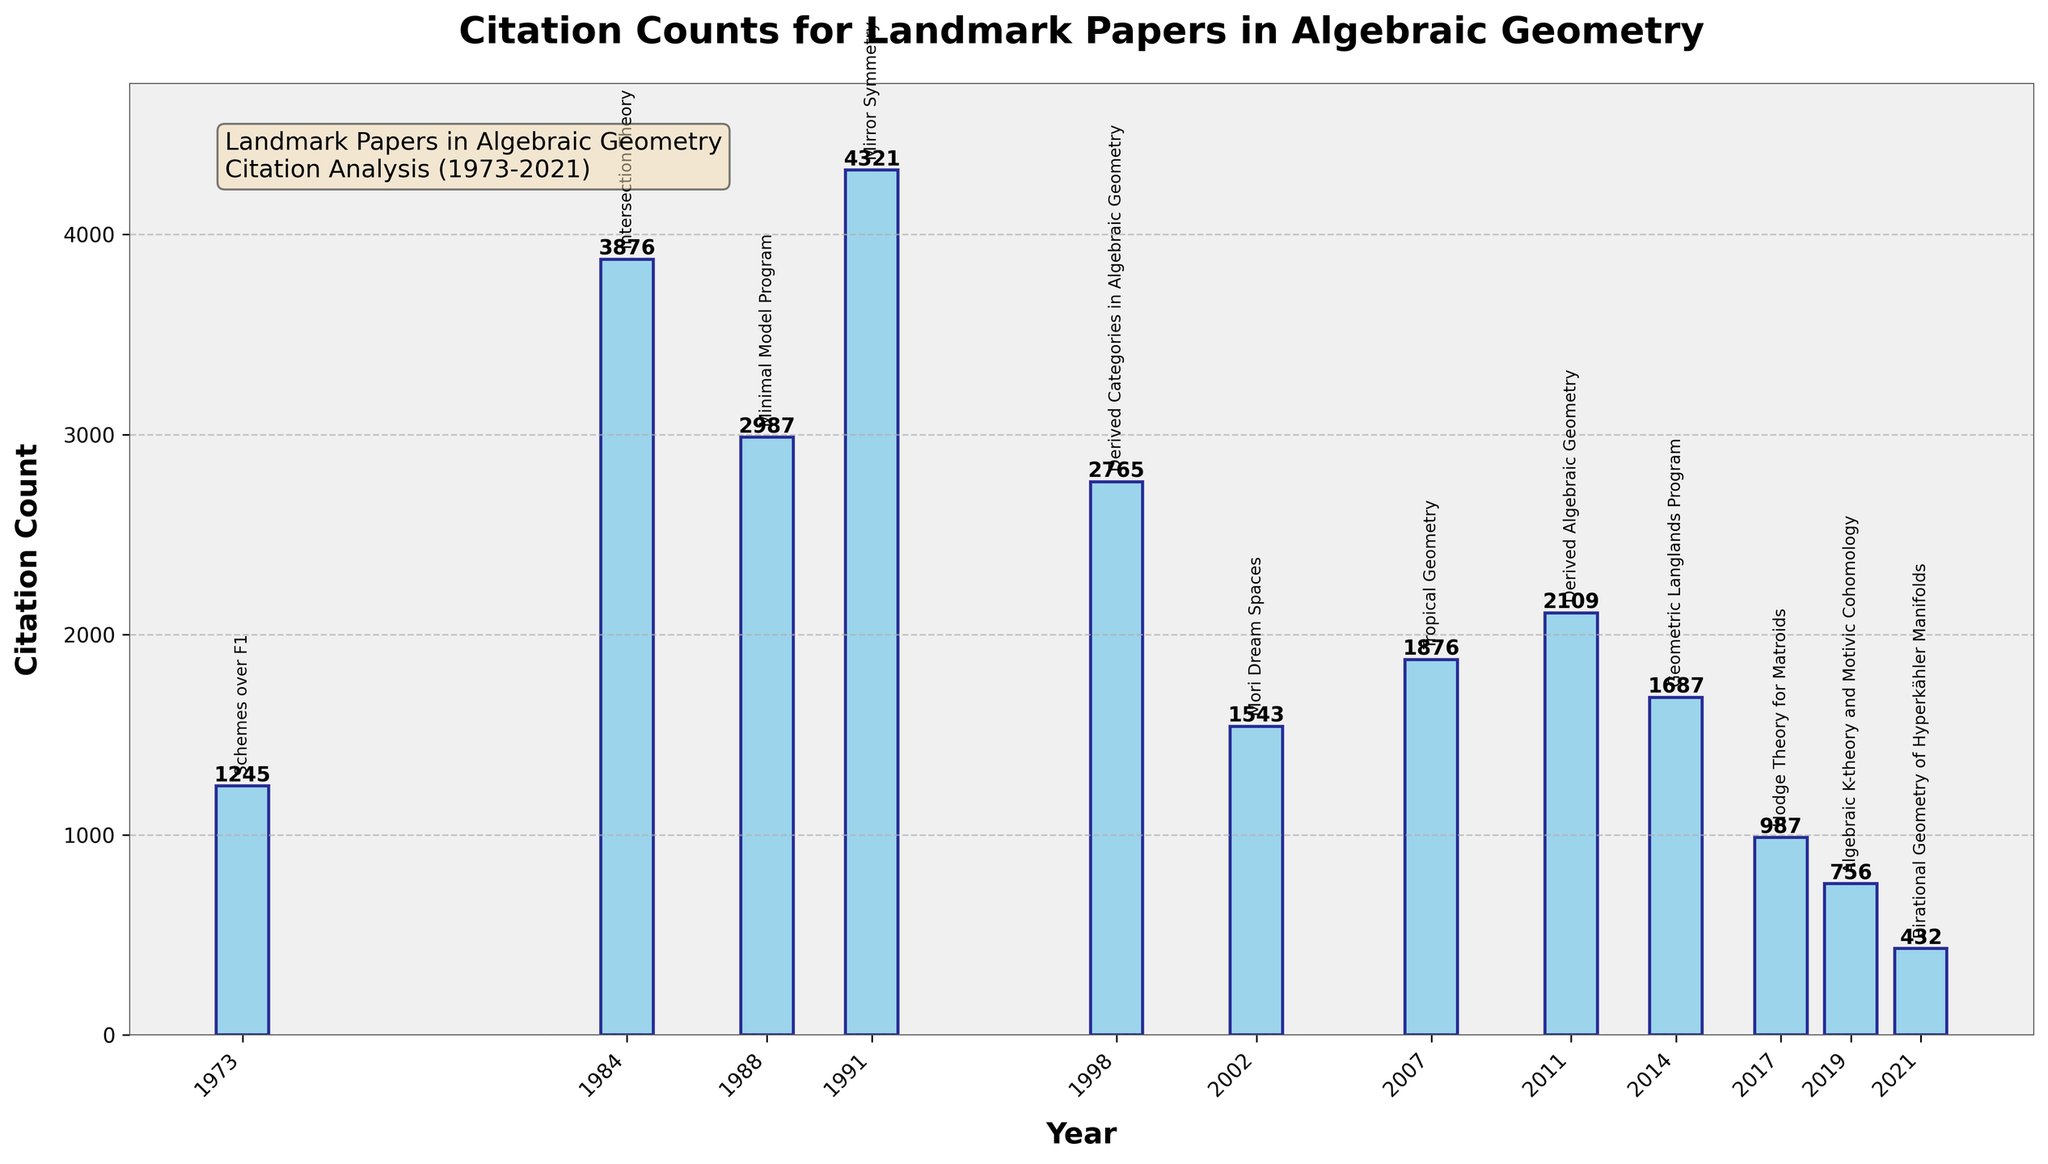How many more citations does "Mirror Symmetry" have compared to "Derived Categories in Algebraic Geometry"? "Mirror Symmetry" has 4321 citations and "Derived Categories in Algebraic Geometry" has 2765 citations. To find the difference, subtract the latter from the former: 4321 - 2765 = 1556.
Answer: 1556 Which paper has the highest citation count? By looking at the height of the bars, the tallest bar corresponds to "Mirror Symmetry" with a citation count of 4321.
Answer: Mirror Symmetry What is the total number of citations for papers published before the year 2000? Sum the citation counts of papers published before 2000: "Schemes over F1" (1245), "Intersection Theory" (3876), "Minimal Model Program" (2987), "Mirror Symmetry" (4321), "Derived Categories in Algebraic Geometry" (2765). Therefore, the total is 1245 + 3876 + 2987 + 4321 + 2765 = 15194.
Answer: 15194 What is the average citation count for papers published after 2010? Sum the citation counts of papers published after 2010 and then divide by the number of papers: "Derived Algebraic Geometry" (2109), "Geometric Langlands Program" (1687), "Hodge Theory for Matroids" (987), "Algebraic K-theory and Motivic Cohomology" (756), "Birational Geometry of Hyperkähler Manifolds" (432). The total is 2109 + 1687 + 987 + 756 + 432 = 5971. There are 5 papers, so the average is 5971 / 5 = 1194.2.
Answer: 1194.2 Which paper has the lowest citation count, and how many citations does it have? The shortest bar represents "Birational Geometry of Hyperkähler Manifolds" with a citation count of 432.
Answer: Birational Geometry of Hyperkähler Manifolds, 432 Is the citation count for "Geometric Langlands Program" greater or lesser than "Mori Dream Spaces"? "Geometric Langlands Program" has 1687 citations and "Mori Dream Spaces" has 1543 citations. Since 1687 is greater than 1543, the former has a higher citation count.
Answer: Greater What is the combined citation count for "Minimal Model Program" and "Mori Dream Spaces"? Add the citation counts of "Minimal Model Program" (2987) and "Mori Dream Spaces" (1543): 2987 + 1543 = 4530.
Answer: 4530 Which year features the highest citation count for a landmark paper, and what is that count? The tallest bar corresponding to "Mirror Symmetry" shows the highest citation count of 4321, published in 1991.
Answer: 1991, 4321 What is the visual attribute used to annotate the titles of the papers on the chart? The titles are annotated with text labels placed above the bars.
Answer: Text labels How does the citation count of "Tropical Geometry" compare with "Derived Algebraic Geometry"? "Tropical Geometry" has 1876 citations, while "Derived Algebraic Geometry" has 2109 citations. Since 1876 is less than 2109, "Tropical Geometry" has fewer citations.
Answer: Fewer 